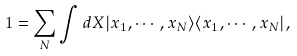<formula> <loc_0><loc_0><loc_500><loc_500>1 = \sum _ { N } \int d X | x _ { 1 } , \cdots , x _ { N } \rangle \langle x _ { 1 } , \cdots , x _ { N } | ,</formula> 